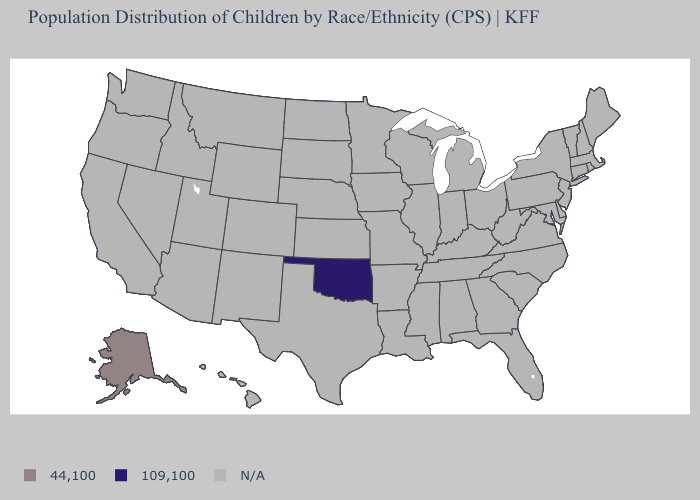Name the states that have a value in the range N/A?
Give a very brief answer. Alabama, Arizona, Arkansas, California, Colorado, Connecticut, Delaware, Florida, Georgia, Hawaii, Idaho, Illinois, Indiana, Iowa, Kansas, Kentucky, Louisiana, Maine, Maryland, Massachusetts, Michigan, Minnesota, Mississippi, Missouri, Montana, Nebraska, Nevada, New Hampshire, New Jersey, New Mexico, New York, North Carolina, North Dakota, Ohio, Oregon, Pennsylvania, Rhode Island, South Carolina, South Dakota, Tennessee, Texas, Utah, Vermont, Virginia, Washington, West Virginia, Wisconsin, Wyoming. Name the states that have a value in the range N/A?
Short answer required. Alabama, Arizona, Arkansas, California, Colorado, Connecticut, Delaware, Florida, Georgia, Hawaii, Idaho, Illinois, Indiana, Iowa, Kansas, Kentucky, Louisiana, Maine, Maryland, Massachusetts, Michigan, Minnesota, Mississippi, Missouri, Montana, Nebraska, Nevada, New Hampshire, New Jersey, New Mexico, New York, North Carolina, North Dakota, Ohio, Oregon, Pennsylvania, Rhode Island, South Carolina, South Dakota, Tennessee, Texas, Utah, Vermont, Virginia, Washington, West Virginia, Wisconsin, Wyoming. What is the lowest value in the USA?
Keep it brief. 109,100. What is the lowest value in the USA?
Give a very brief answer. 109,100. What is the value of Pennsylvania?
Concise answer only. N/A. How many symbols are there in the legend?
Keep it brief. 3. What is the value of Washington?
Keep it brief. N/A. Name the states that have a value in the range 44,100?
Concise answer only. Alaska. Which states have the highest value in the USA?
Short answer required. Alaska. Name the states that have a value in the range 109,100?
Write a very short answer. Oklahoma. Does Oklahoma have the lowest value in the USA?
Be succinct. Yes. 